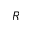Convert formula to latex. <formula><loc_0><loc_0><loc_500><loc_500>R</formula> 